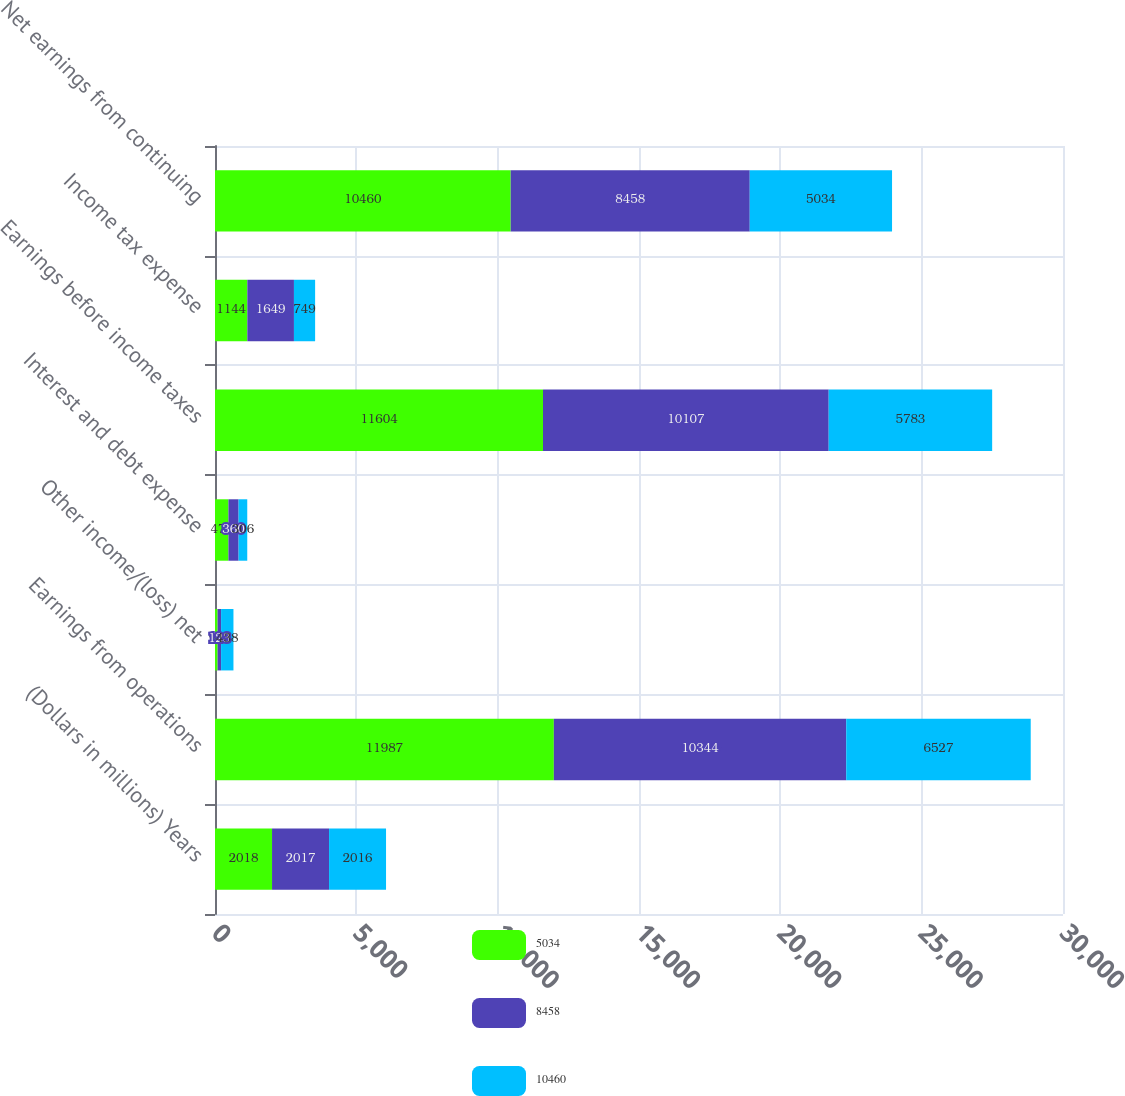<chart> <loc_0><loc_0><loc_500><loc_500><stacked_bar_chart><ecel><fcel>(Dollars in millions) Years<fcel>Earnings from operations<fcel>Other income/(loss) net<fcel>Interest and debt expense<fcel>Earnings before income taxes<fcel>Income tax expense<fcel>Net earnings from continuing<nl><fcel>5034<fcel>2018<fcel>11987<fcel>92<fcel>475<fcel>11604<fcel>1144<fcel>10460<nl><fcel>8458<fcel>2017<fcel>10344<fcel>123<fcel>360<fcel>10107<fcel>1649<fcel>8458<nl><fcel>10460<fcel>2016<fcel>6527<fcel>438<fcel>306<fcel>5783<fcel>749<fcel>5034<nl></chart> 